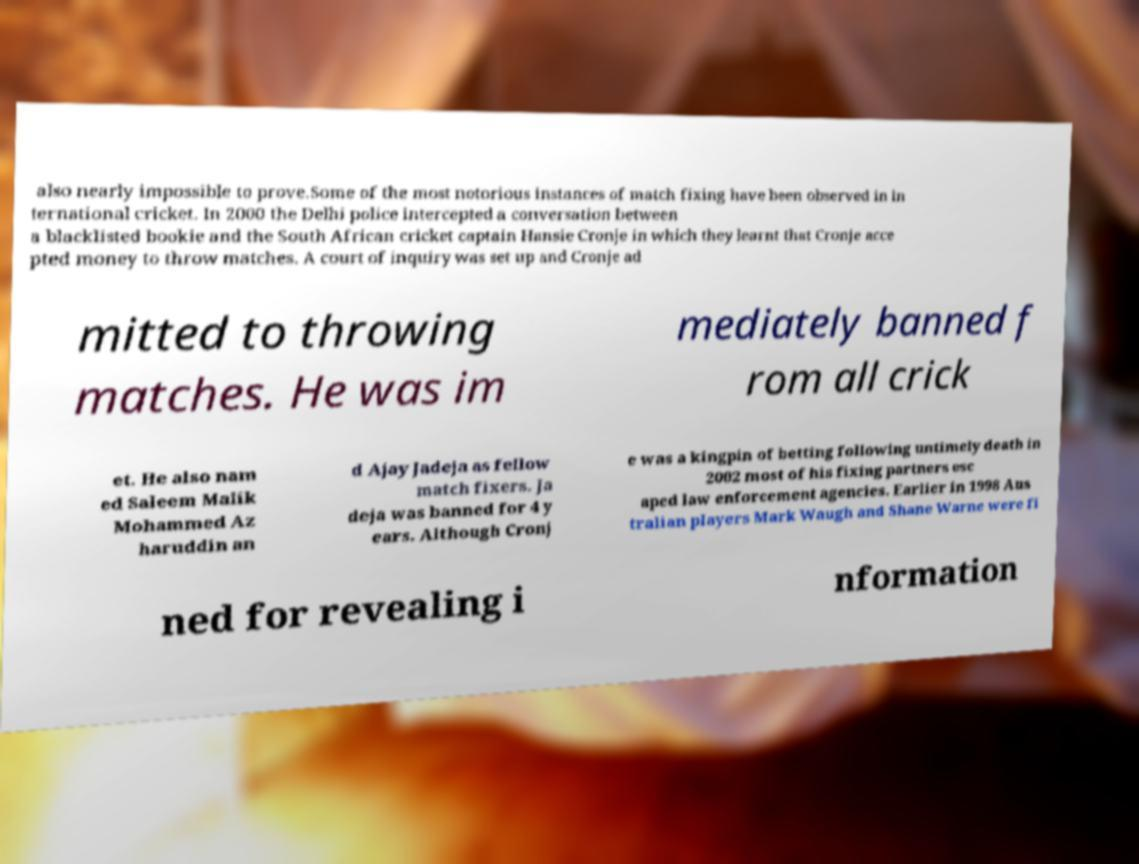What messages or text are displayed in this image? I need them in a readable, typed format. also nearly impossible to prove.Some of the most notorious instances of match fixing have been observed in in ternational cricket. In 2000 the Delhi police intercepted a conversation between a blacklisted bookie and the South African cricket captain Hansie Cronje in which they learnt that Cronje acce pted money to throw matches. A court of inquiry was set up and Cronje ad mitted to throwing matches. He was im mediately banned f rom all crick et. He also nam ed Saleem Malik Mohammed Az haruddin an d Ajay Jadeja as fellow match fixers. Ja deja was banned for 4 y ears. Although Cronj e was a kingpin of betting following untimely death in 2002 most of his fixing partners esc aped law enforcement agencies. Earlier in 1998 Aus tralian players Mark Waugh and Shane Warne were fi ned for revealing i nformation 